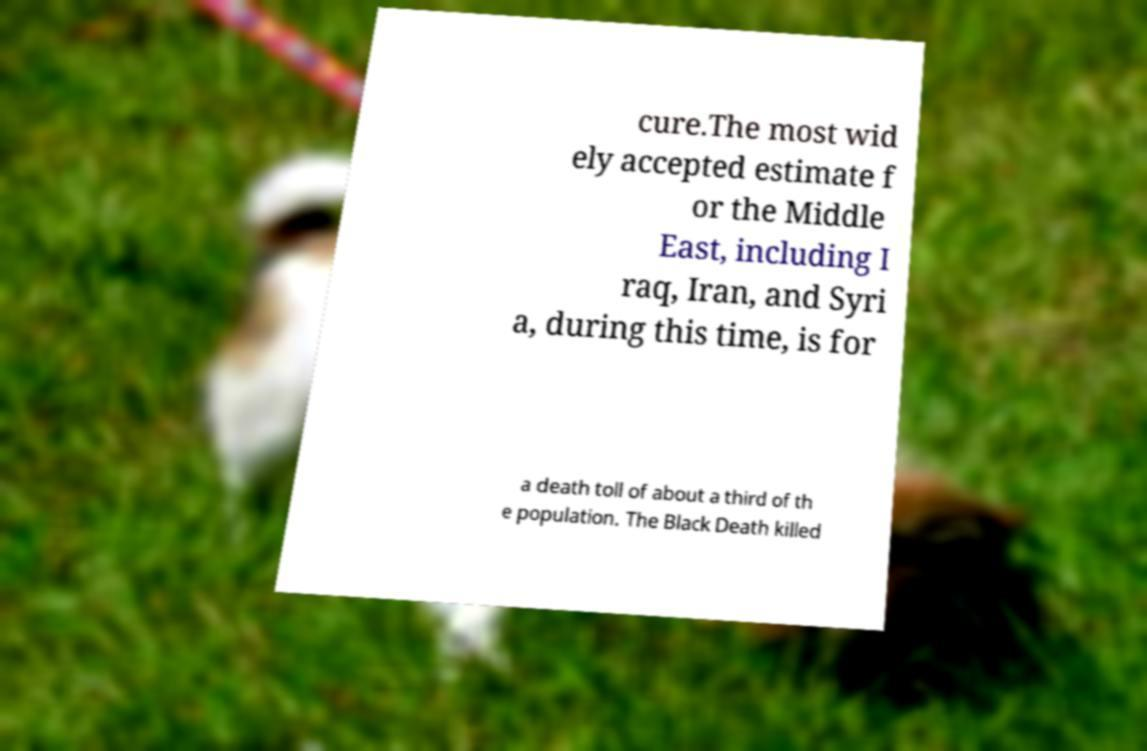Can you accurately transcribe the text from the provided image for me? cure.The most wid ely accepted estimate f or the Middle East, including I raq, Iran, and Syri a, during this time, is for a death toll of about a third of th e population. The Black Death killed 